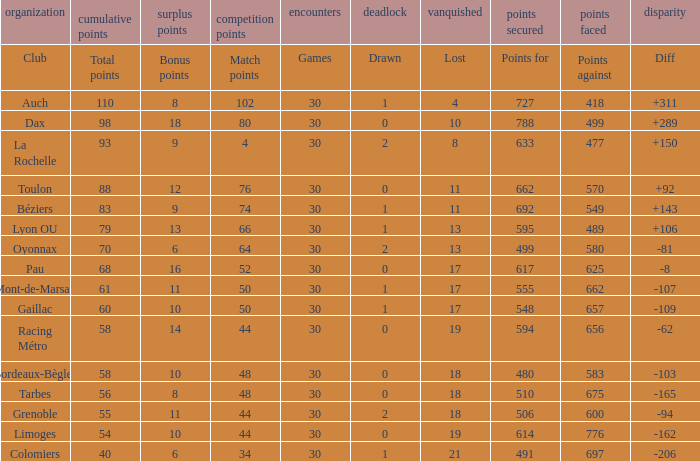What is the number of games for a club that has 34 match points? 30.0. 